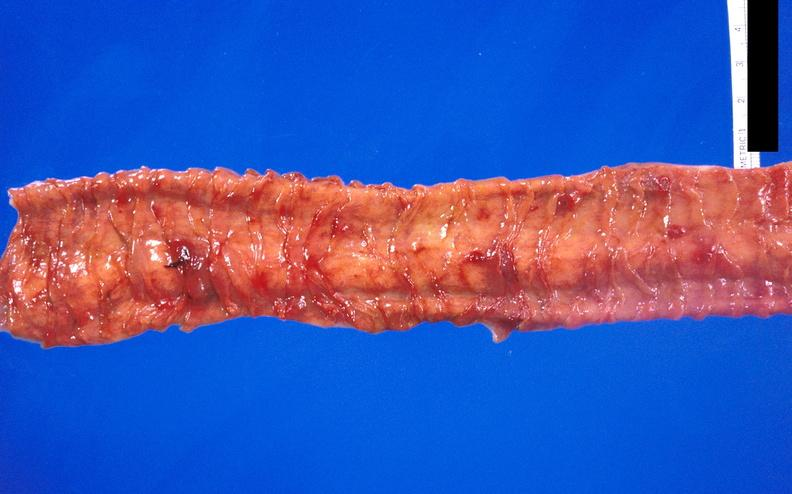what is present?
Answer the question using a single word or phrase. Gastrointestinal 